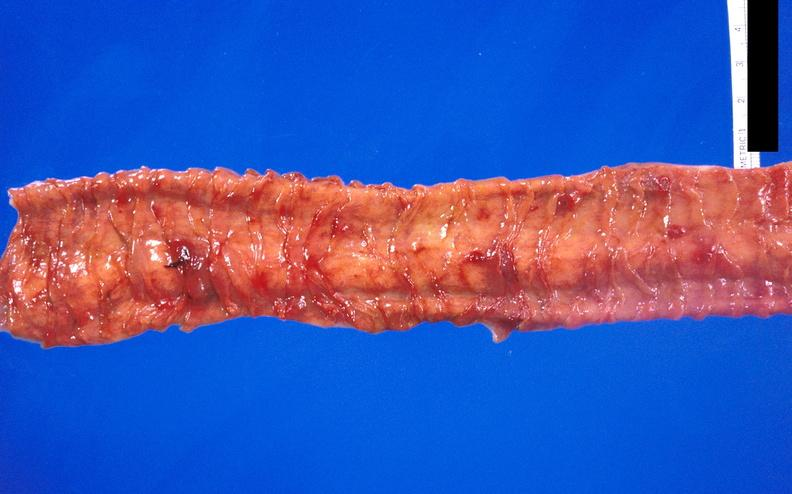what is present?
Answer the question using a single word or phrase. Gastrointestinal 